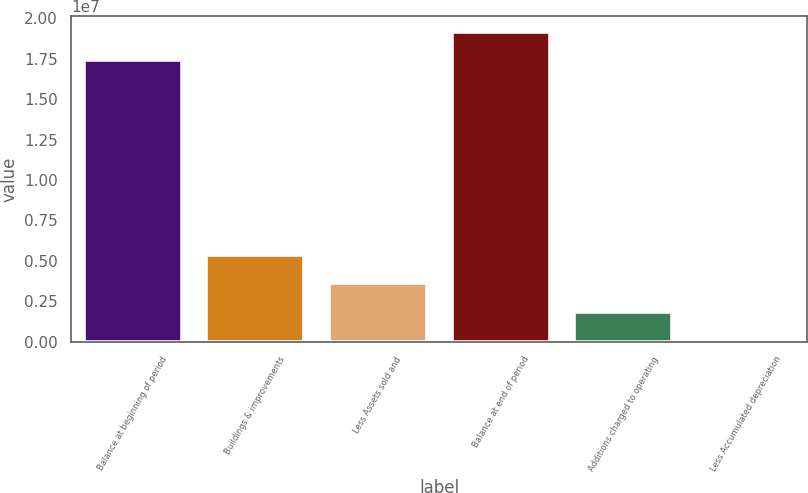Convert chart to OTSL. <chart><loc_0><loc_0><loc_500><loc_500><bar_chart><fcel>Balance at beginning of period<fcel>Buildings & improvements<fcel>Less Assets sold and<fcel>Balance at end of period<fcel>Additions charged to operating<fcel>Less Accumulated depreciation<nl><fcel>1.74329e+07<fcel>5.34933e+06<fcel>3.60292e+06<fcel>1.91793e+07<fcel>1.8565e+06<fcel>110084<nl></chart> 